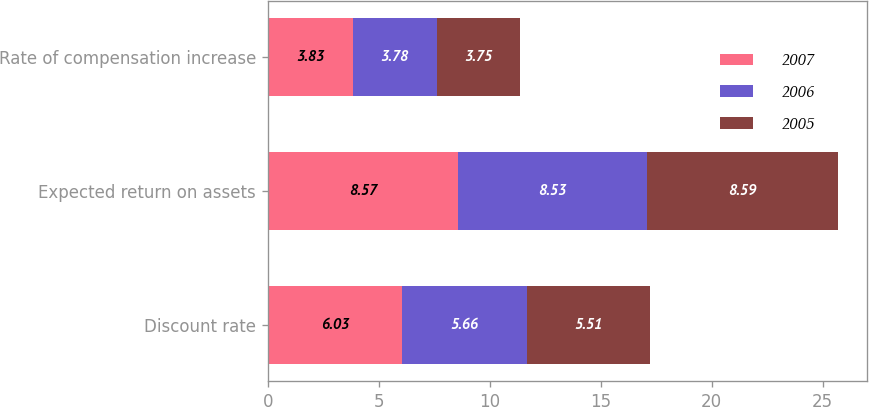Convert chart to OTSL. <chart><loc_0><loc_0><loc_500><loc_500><stacked_bar_chart><ecel><fcel>Discount rate<fcel>Expected return on assets<fcel>Rate of compensation increase<nl><fcel>2007<fcel>6.03<fcel>8.57<fcel>3.83<nl><fcel>2006<fcel>5.66<fcel>8.53<fcel>3.78<nl><fcel>2005<fcel>5.51<fcel>8.59<fcel>3.75<nl></chart> 